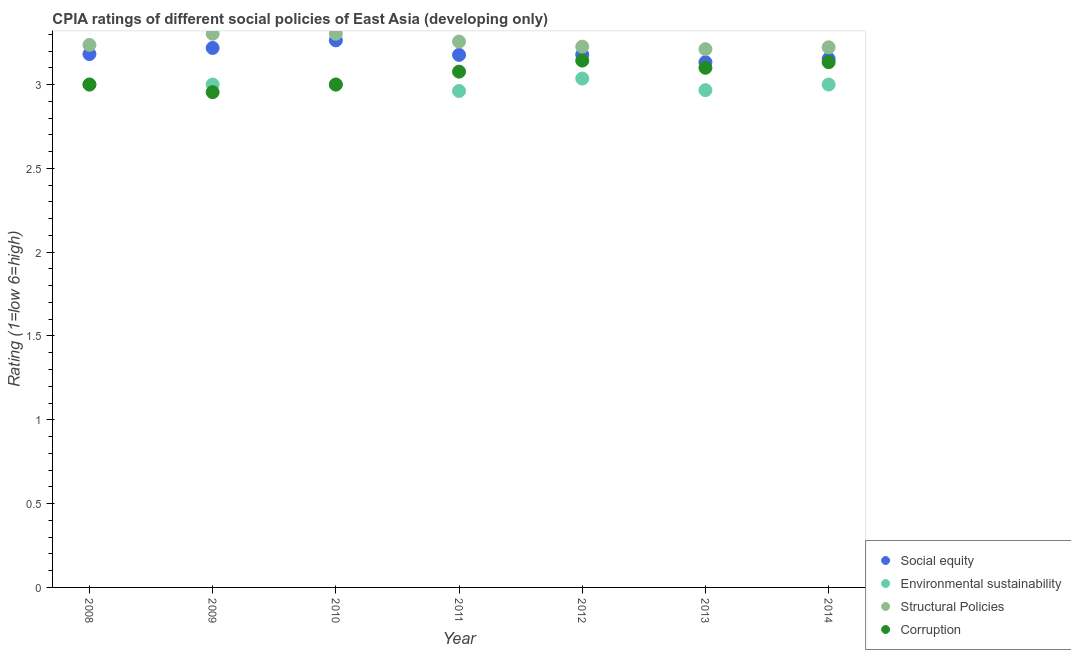How many different coloured dotlines are there?
Your answer should be compact. 4. What is the cpia rating of social equity in 2008?
Ensure brevity in your answer.  3.18. Across all years, what is the maximum cpia rating of social equity?
Offer a very short reply. 3.26. Across all years, what is the minimum cpia rating of social equity?
Make the answer very short. 3.13. In which year was the cpia rating of social equity maximum?
Provide a succinct answer. 2010. What is the total cpia rating of structural policies in the graph?
Give a very brief answer. 22.76. What is the difference between the cpia rating of structural policies in 2008 and that in 2014?
Make the answer very short. 0.01. What is the difference between the cpia rating of corruption in 2012 and the cpia rating of environmental sustainability in 2008?
Provide a short and direct response. 0.14. What is the average cpia rating of structural policies per year?
Keep it short and to the point. 3.25. In the year 2012, what is the difference between the cpia rating of structural policies and cpia rating of environmental sustainability?
Offer a very short reply. 0.19. In how many years, is the cpia rating of corruption greater than 2.7?
Provide a short and direct response. 7. What is the ratio of the cpia rating of structural policies in 2010 to that in 2013?
Your response must be concise. 1.03. Is the cpia rating of environmental sustainability in 2013 less than that in 2014?
Provide a short and direct response. Yes. What is the difference between the highest and the second highest cpia rating of corruption?
Offer a very short reply. 0.01. What is the difference between the highest and the lowest cpia rating of structural policies?
Offer a very short reply. 0.09. In how many years, is the cpia rating of social equity greater than the average cpia rating of social equity taken over all years?
Provide a short and direct response. 2. Is it the case that in every year, the sum of the cpia rating of structural policies and cpia rating of environmental sustainability is greater than the sum of cpia rating of corruption and cpia rating of social equity?
Offer a very short reply. Yes. Does the cpia rating of corruption monotonically increase over the years?
Give a very brief answer. No. How many years are there in the graph?
Give a very brief answer. 7. What is the difference between two consecutive major ticks on the Y-axis?
Keep it short and to the point. 0.5. Does the graph contain any zero values?
Provide a succinct answer. No. How many legend labels are there?
Keep it short and to the point. 4. What is the title of the graph?
Keep it short and to the point. CPIA ratings of different social policies of East Asia (developing only). Does "UNTA" appear as one of the legend labels in the graph?
Provide a short and direct response. No. What is the label or title of the X-axis?
Offer a very short reply. Year. What is the Rating (1=low 6=high) of Social equity in 2008?
Ensure brevity in your answer.  3.18. What is the Rating (1=low 6=high) of Structural Policies in 2008?
Offer a very short reply. 3.24. What is the Rating (1=low 6=high) of Social equity in 2009?
Offer a terse response. 3.22. What is the Rating (1=low 6=high) in Structural Policies in 2009?
Keep it short and to the point. 3.3. What is the Rating (1=low 6=high) of Corruption in 2009?
Keep it short and to the point. 2.95. What is the Rating (1=low 6=high) of Social equity in 2010?
Your answer should be very brief. 3.26. What is the Rating (1=low 6=high) in Structural Policies in 2010?
Provide a succinct answer. 3.3. What is the Rating (1=low 6=high) in Corruption in 2010?
Offer a terse response. 3. What is the Rating (1=low 6=high) in Social equity in 2011?
Ensure brevity in your answer.  3.18. What is the Rating (1=low 6=high) of Environmental sustainability in 2011?
Offer a terse response. 2.96. What is the Rating (1=low 6=high) of Structural Policies in 2011?
Provide a succinct answer. 3.26. What is the Rating (1=low 6=high) of Corruption in 2011?
Make the answer very short. 3.08. What is the Rating (1=low 6=high) of Social equity in 2012?
Your answer should be very brief. 3.18. What is the Rating (1=low 6=high) in Environmental sustainability in 2012?
Your answer should be compact. 3.04. What is the Rating (1=low 6=high) in Structural Policies in 2012?
Offer a terse response. 3.23. What is the Rating (1=low 6=high) in Corruption in 2012?
Offer a very short reply. 3.14. What is the Rating (1=low 6=high) of Social equity in 2013?
Make the answer very short. 3.13. What is the Rating (1=low 6=high) of Environmental sustainability in 2013?
Your response must be concise. 2.97. What is the Rating (1=low 6=high) in Structural Policies in 2013?
Give a very brief answer. 3.21. What is the Rating (1=low 6=high) of Corruption in 2013?
Give a very brief answer. 3.1. What is the Rating (1=low 6=high) of Social equity in 2014?
Offer a very short reply. 3.15. What is the Rating (1=low 6=high) in Environmental sustainability in 2014?
Make the answer very short. 3. What is the Rating (1=low 6=high) of Structural Policies in 2014?
Offer a terse response. 3.22. What is the Rating (1=low 6=high) in Corruption in 2014?
Make the answer very short. 3.13. Across all years, what is the maximum Rating (1=low 6=high) of Social equity?
Offer a very short reply. 3.26. Across all years, what is the maximum Rating (1=low 6=high) in Environmental sustainability?
Keep it short and to the point. 3.04. Across all years, what is the maximum Rating (1=low 6=high) of Structural Policies?
Offer a very short reply. 3.3. Across all years, what is the maximum Rating (1=low 6=high) of Corruption?
Keep it short and to the point. 3.14. Across all years, what is the minimum Rating (1=low 6=high) in Social equity?
Your response must be concise. 3.13. Across all years, what is the minimum Rating (1=low 6=high) in Environmental sustainability?
Give a very brief answer. 2.96. Across all years, what is the minimum Rating (1=low 6=high) in Structural Policies?
Ensure brevity in your answer.  3.21. Across all years, what is the minimum Rating (1=low 6=high) in Corruption?
Offer a terse response. 2.95. What is the total Rating (1=low 6=high) in Social equity in the graph?
Your answer should be compact. 22.31. What is the total Rating (1=low 6=high) in Environmental sustainability in the graph?
Provide a succinct answer. 20.96. What is the total Rating (1=low 6=high) of Structural Policies in the graph?
Make the answer very short. 22.76. What is the total Rating (1=low 6=high) of Corruption in the graph?
Make the answer very short. 21.41. What is the difference between the Rating (1=low 6=high) in Social equity in 2008 and that in 2009?
Provide a succinct answer. -0.04. What is the difference between the Rating (1=low 6=high) of Structural Policies in 2008 and that in 2009?
Keep it short and to the point. -0.07. What is the difference between the Rating (1=low 6=high) of Corruption in 2008 and that in 2009?
Offer a very short reply. 0.05. What is the difference between the Rating (1=low 6=high) in Social equity in 2008 and that in 2010?
Provide a short and direct response. -0.08. What is the difference between the Rating (1=low 6=high) in Structural Policies in 2008 and that in 2010?
Provide a short and direct response. -0.07. What is the difference between the Rating (1=low 6=high) of Corruption in 2008 and that in 2010?
Offer a terse response. 0. What is the difference between the Rating (1=low 6=high) of Social equity in 2008 and that in 2011?
Ensure brevity in your answer.  0. What is the difference between the Rating (1=low 6=high) of Environmental sustainability in 2008 and that in 2011?
Give a very brief answer. 0.04. What is the difference between the Rating (1=low 6=high) of Structural Policies in 2008 and that in 2011?
Your answer should be compact. -0.02. What is the difference between the Rating (1=low 6=high) of Corruption in 2008 and that in 2011?
Provide a short and direct response. -0.08. What is the difference between the Rating (1=low 6=high) of Social equity in 2008 and that in 2012?
Offer a terse response. 0. What is the difference between the Rating (1=low 6=high) in Environmental sustainability in 2008 and that in 2012?
Offer a terse response. -0.04. What is the difference between the Rating (1=low 6=high) in Structural Policies in 2008 and that in 2012?
Offer a terse response. 0.01. What is the difference between the Rating (1=low 6=high) of Corruption in 2008 and that in 2012?
Keep it short and to the point. -0.14. What is the difference between the Rating (1=low 6=high) in Social equity in 2008 and that in 2013?
Ensure brevity in your answer.  0.05. What is the difference between the Rating (1=low 6=high) of Structural Policies in 2008 and that in 2013?
Keep it short and to the point. 0.03. What is the difference between the Rating (1=low 6=high) of Social equity in 2008 and that in 2014?
Give a very brief answer. 0.03. What is the difference between the Rating (1=low 6=high) in Environmental sustainability in 2008 and that in 2014?
Keep it short and to the point. 0. What is the difference between the Rating (1=low 6=high) of Structural Policies in 2008 and that in 2014?
Provide a short and direct response. 0.01. What is the difference between the Rating (1=low 6=high) in Corruption in 2008 and that in 2014?
Your answer should be very brief. -0.13. What is the difference between the Rating (1=low 6=high) of Social equity in 2009 and that in 2010?
Provide a succinct answer. -0.05. What is the difference between the Rating (1=low 6=high) of Structural Policies in 2009 and that in 2010?
Provide a succinct answer. 0. What is the difference between the Rating (1=low 6=high) of Corruption in 2009 and that in 2010?
Offer a very short reply. -0.05. What is the difference between the Rating (1=low 6=high) of Social equity in 2009 and that in 2011?
Make the answer very short. 0.04. What is the difference between the Rating (1=low 6=high) in Environmental sustainability in 2009 and that in 2011?
Make the answer very short. 0.04. What is the difference between the Rating (1=low 6=high) of Structural Policies in 2009 and that in 2011?
Offer a very short reply. 0.05. What is the difference between the Rating (1=low 6=high) in Corruption in 2009 and that in 2011?
Give a very brief answer. -0.12. What is the difference between the Rating (1=low 6=high) of Social equity in 2009 and that in 2012?
Make the answer very short. 0.04. What is the difference between the Rating (1=low 6=high) of Environmental sustainability in 2009 and that in 2012?
Make the answer very short. -0.04. What is the difference between the Rating (1=low 6=high) in Structural Policies in 2009 and that in 2012?
Your response must be concise. 0.08. What is the difference between the Rating (1=low 6=high) in Corruption in 2009 and that in 2012?
Offer a terse response. -0.19. What is the difference between the Rating (1=low 6=high) of Social equity in 2009 and that in 2013?
Provide a short and direct response. 0.08. What is the difference between the Rating (1=low 6=high) in Environmental sustainability in 2009 and that in 2013?
Your answer should be compact. 0.03. What is the difference between the Rating (1=low 6=high) in Structural Policies in 2009 and that in 2013?
Offer a terse response. 0.09. What is the difference between the Rating (1=low 6=high) in Corruption in 2009 and that in 2013?
Provide a succinct answer. -0.15. What is the difference between the Rating (1=low 6=high) of Social equity in 2009 and that in 2014?
Your answer should be very brief. 0.06. What is the difference between the Rating (1=low 6=high) of Environmental sustainability in 2009 and that in 2014?
Ensure brevity in your answer.  0. What is the difference between the Rating (1=low 6=high) in Structural Policies in 2009 and that in 2014?
Your answer should be compact. 0.08. What is the difference between the Rating (1=low 6=high) in Corruption in 2009 and that in 2014?
Keep it short and to the point. -0.18. What is the difference between the Rating (1=low 6=high) of Social equity in 2010 and that in 2011?
Offer a terse response. 0.09. What is the difference between the Rating (1=low 6=high) of Environmental sustainability in 2010 and that in 2011?
Keep it short and to the point. 0.04. What is the difference between the Rating (1=low 6=high) in Structural Policies in 2010 and that in 2011?
Provide a succinct answer. 0.05. What is the difference between the Rating (1=low 6=high) of Corruption in 2010 and that in 2011?
Your answer should be compact. -0.08. What is the difference between the Rating (1=low 6=high) of Social equity in 2010 and that in 2012?
Provide a short and direct response. 0.09. What is the difference between the Rating (1=low 6=high) of Environmental sustainability in 2010 and that in 2012?
Give a very brief answer. -0.04. What is the difference between the Rating (1=low 6=high) of Structural Policies in 2010 and that in 2012?
Give a very brief answer. 0.08. What is the difference between the Rating (1=low 6=high) of Corruption in 2010 and that in 2012?
Provide a succinct answer. -0.14. What is the difference between the Rating (1=low 6=high) of Social equity in 2010 and that in 2013?
Your answer should be very brief. 0.13. What is the difference between the Rating (1=low 6=high) in Structural Policies in 2010 and that in 2013?
Make the answer very short. 0.09. What is the difference between the Rating (1=low 6=high) in Corruption in 2010 and that in 2013?
Keep it short and to the point. -0.1. What is the difference between the Rating (1=low 6=high) in Social equity in 2010 and that in 2014?
Provide a succinct answer. 0.11. What is the difference between the Rating (1=low 6=high) in Environmental sustainability in 2010 and that in 2014?
Provide a short and direct response. 0. What is the difference between the Rating (1=low 6=high) in Structural Policies in 2010 and that in 2014?
Provide a succinct answer. 0.08. What is the difference between the Rating (1=low 6=high) in Corruption in 2010 and that in 2014?
Provide a succinct answer. -0.13. What is the difference between the Rating (1=low 6=high) in Social equity in 2011 and that in 2012?
Make the answer very short. -0. What is the difference between the Rating (1=low 6=high) of Environmental sustainability in 2011 and that in 2012?
Provide a short and direct response. -0.07. What is the difference between the Rating (1=low 6=high) in Structural Policies in 2011 and that in 2012?
Offer a very short reply. 0.03. What is the difference between the Rating (1=low 6=high) in Corruption in 2011 and that in 2012?
Provide a short and direct response. -0.07. What is the difference between the Rating (1=low 6=high) in Social equity in 2011 and that in 2013?
Offer a very short reply. 0.04. What is the difference between the Rating (1=low 6=high) of Environmental sustainability in 2011 and that in 2013?
Ensure brevity in your answer.  -0.01. What is the difference between the Rating (1=low 6=high) of Structural Policies in 2011 and that in 2013?
Ensure brevity in your answer.  0.05. What is the difference between the Rating (1=low 6=high) in Corruption in 2011 and that in 2013?
Give a very brief answer. -0.02. What is the difference between the Rating (1=low 6=high) in Social equity in 2011 and that in 2014?
Your answer should be compact. 0.02. What is the difference between the Rating (1=low 6=high) in Environmental sustainability in 2011 and that in 2014?
Offer a very short reply. -0.04. What is the difference between the Rating (1=low 6=high) in Structural Policies in 2011 and that in 2014?
Give a very brief answer. 0.03. What is the difference between the Rating (1=low 6=high) of Corruption in 2011 and that in 2014?
Provide a succinct answer. -0.06. What is the difference between the Rating (1=low 6=high) in Social equity in 2012 and that in 2013?
Keep it short and to the point. 0.05. What is the difference between the Rating (1=low 6=high) of Environmental sustainability in 2012 and that in 2013?
Your answer should be compact. 0.07. What is the difference between the Rating (1=low 6=high) in Structural Policies in 2012 and that in 2013?
Provide a short and direct response. 0.02. What is the difference between the Rating (1=low 6=high) in Corruption in 2012 and that in 2013?
Give a very brief answer. 0.04. What is the difference between the Rating (1=low 6=high) of Social equity in 2012 and that in 2014?
Offer a terse response. 0.03. What is the difference between the Rating (1=low 6=high) of Environmental sustainability in 2012 and that in 2014?
Your answer should be very brief. 0.04. What is the difference between the Rating (1=low 6=high) in Structural Policies in 2012 and that in 2014?
Offer a very short reply. 0. What is the difference between the Rating (1=low 6=high) of Corruption in 2012 and that in 2014?
Provide a succinct answer. 0.01. What is the difference between the Rating (1=low 6=high) of Social equity in 2013 and that in 2014?
Give a very brief answer. -0.02. What is the difference between the Rating (1=low 6=high) of Environmental sustainability in 2013 and that in 2014?
Your answer should be very brief. -0.03. What is the difference between the Rating (1=low 6=high) in Structural Policies in 2013 and that in 2014?
Give a very brief answer. -0.01. What is the difference between the Rating (1=low 6=high) of Corruption in 2013 and that in 2014?
Your answer should be compact. -0.03. What is the difference between the Rating (1=low 6=high) in Social equity in 2008 and the Rating (1=low 6=high) in Environmental sustainability in 2009?
Your answer should be compact. 0.18. What is the difference between the Rating (1=low 6=high) of Social equity in 2008 and the Rating (1=low 6=high) of Structural Policies in 2009?
Your response must be concise. -0.12. What is the difference between the Rating (1=low 6=high) in Social equity in 2008 and the Rating (1=low 6=high) in Corruption in 2009?
Make the answer very short. 0.23. What is the difference between the Rating (1=low 6=high) of Environmental sustainability in 2008 and the Rating (1=low 6=high) of Structural Policies in 2009?
Provide a short and direct response. -0.3. What is the difference between the Rating (1=low 6=high) of Environmental sustainability in 2008 and the Rating (1=low 6=high) of Corruption in 2009?
Ensure brevity in your answer.  0.05. What is the difference between the Rating (1=low 6=high) of Structural Policies in 2008 and the Rating (1=low 6=high) of Corruption in 2009?
Ensure brevity in your answer.  0.28. What is the difference between the Rating (1=low 6=high) in Social equity in 2008 and the Rating (1=low 6=high) in Environmental sustainability in 2010?
Your answer should be compact. 0.18. What is the difference between the Rating (1=low 6=high) of Social equity in 2008 and the Rating (1=low 6=high) of Structural Policies in 2010?
Your answer should be very brief. -0.12. What is the difference between the Rating (1=low 6=high) of Social equity in 2008 and the Rating (1=low 6=high) of Corruption in 2010?
Offer a terse response. 0.18. What is the difference between the Rating (1=low 6=high) of Environmental sustainability in 2008 and the Rating (1=low 6=high) of Structural Policies in 2010?
Your answer should be compact. -0.3. What is the difference between the Rating (1=low 6=high) in Structural Policies in 2008 and the Rating (1=low 6=high) in Corruption in 2010?
Offer a terse response. 0.24. What is the difference between the Rating (1=low 6=high) of Social equity in 2008 and the Rating (1=low 6=high) of Environmental sustainability in 2011?
Ensure brevity in your answer.  0.22. What is the difference between the Rating (1=low 6=high) of Social equity in 2008 and the Rating (1=low 6=high) of Structural Policies in 2011?
Your answer should be very brief. -0.07. What is the difference between the Rating (1=low 6=high) of Social equity in 2008 and the Rating (1=low 6=high) of Corruption in 2011?
Make the answer very short. 0.1. What is the difference between the Rating (1=low 6=high) of Environmental sustainability in 2008 and the Rating (1=low 6=high) of Structural Policies in 2011?
Your answer should be very brief. -0.26. What is the difference between the Rating (1=low 6=high) in Environmental sustainability in 2008 and the Rating (1=low 6=high) in Corruption in 2011?
Give a very brief answer. -0.08. What is the difference between the Rating (1=low 6=high) in Structural Policies in 2008 and the Rating (1=low 6=high) in Corruption in 2011?
Your response must be concise. 0.16. What is the difference between the Rating (1=low 6=high) in Social equity in 2008 and the Rating (1=low 6=high) in Environmental sustainability in 2012?
Offer a terse response. 0.15. What is the difference between the Rating (1=low 6=high) in Social equity in 2008 and the Rating (1=low 6=high) in Structural Policies in 2012?
Provide a short and direct response. -0.04. What is the difference between the Rating (1=low 6=high) in Social equity in 2008 and the Rating (1=low 6=high) in Corruption in 2012?
Your answer should be compact. 0.04. What is the difference between the Rating (1=low 6=high) in Environmental sustainability in 2008 and the Rating (1=low 6=high) in Structural Policies in 2012?
Keep it short and to the point. -0.23. What is the difference between the Rating (1=low 6=high) of Environmental sustainability in 2008 and the Rating (1=low 6=high) of Corruption in 2012?
Offer a very short reply. -0.14. What is the difference between the Rating (1=low 6=high) in Structural Policies in 2008 and the Rating (1=low 6=high) in Corruption in 2012?
Provide a short and direct response. 0.09. What is the difference between the Rating (1=low 6=high) of Social equity in 2008 and the Rating (1=low 6=high) of Environmental sustainability in 2013?
Offer a very short reply. 0.22. What is the difference between the Rating (1=low 6=high) in Social equity in 2008 and the Rating (1=low 6=high) in Structural Policies in 2013?
Give a very brief answer. -0.03. What is the difference between the Rating (1=low 6=high) of Social equity in 2008 and the Rating (1=low 6=high) of Corruption in 2013?
Keep it short and to the point. 0.08. What is the difference between the Rating (1=low 6=high) in Environmental sustainability in 2008 and the Rating (1=low 6=high) in Structural Policies in 2013?
Offer a very short reply. -0.21. What is the difference between the Rating (1=low 6=high) in Environmental sustainability in 2008 and the Rating (1=low 6=high) in Corruption in 2013?
Your answer should be very brief. -0.1. What is the difference between the Rating (1=low 6=high) in Structural Policies in 2008 and the Rating (1=low 6=high) in Corruption in 2013?
Your answer should be compact. 0.14. What is the difference between the Rating (1=low 6=high) of Social equity in 2008 and the Rating (1=low 6=high) of Environmental sustainability in 2014?
Make the answer very short. 0.18. What is the difference between the Rating (1=low 6=high) of Social equity in 2008 and the Rating (1=low 6=high) of Structural Policies in 2014?
Keep it short and to the point. -0.04. What is the difference between the Rating (1=low 6=high) of Social equity in 2008 and the Rating (1=low 6=high) of Corruption in 2014?
Your answer should be compact. 0.05. What is the difference between the Rating (1=low 6=high) of Environmental sustainability in 2008 and the Rating (1=low 6=high) of Structural Policies in 2014?
Provide a short and direct response. -0.22. What is the difference between the Rating (1=low 6=high) in Environmental sustainability in 2008 and the Rating (1=low 6=high) in Corruption in 2014?
Provide a succinct answer. -0.13. What is the difference between the Rating (1=low 6=high) of Structural Policies in 2008 and the Rating (1=low 6=high) of Corruption in 2014?
Offer a terse response. 0.1. What is the difference between the Rating (1=low 6=high) in Social equity in 2009 and the Rating (1=low 6=high) in Environmental sustainability in 2010?
Provide a succinct answer. 0.22. What is the difference between the Rating (1=low 6=high) in Social equity in 2009 and the Rating (1=low 6=high) in Structural Policies in 2010?
Give a very brief answer. -0.08. What is the difference between the Rating (1=low 6=high) of Social equity in 2009 and the Rating (1=low 6=high) of Corruption in 2010?
Your response must be concise. 0.22. What is the difference between the Rating (1=low 6=high) in Environmental sustainability in 2009 and the Rating (1=low 6=high) in Structural Policies in 2010?
Give a very brief answer. -0.3. What is the difference between the Rating (1=low 6=high) of Environmental sustainability in 2009 and the Rating (1=low 6=high) of Corruption in 2010?
Your response must be concise. 0. What is the difference between the Rating (1=low 6=high) in Structural Policies in 2009 and the Rating (1=low 6=high) in Corruption in 2010?
Provide a short and direct response. 0.3. What is the difference between the Rating (1=low 6=high) in Social equity in 2009 and the Rating (1=low 6=high) in Environmental sustainability in 2011?
Your response must be concise. 0.26. What is the difference between the Rating (1=low 6=high) in Social equity in 2009 and the Rating (1=low 6=high) in Structural Policies in 2011?
Keep it short and to the point. -0.04. What is the difference between the Rating (1=low 6=high) in Social equity in 2009 and the Rating (1=low 6=high) in Corruption in 2011?
Ensure brevity in your answer.  0.14. What is the difference between the Rating (1=low 6=high) of Environmental sustainability in 2009 and the Rating (1=low 6=high) of Structural Policies in 2011?
Make the answer very short. -0.26. What is the difference between the Rating (1=low 6=high) of Environmental sustainability in 2009 and the Rating (1=low 6=high) of Corruption in 2011?
Your response must be concise. -0.08. What is the difference between the Rating (1=low 6=high) of Structural Policies in 2009 and the Rating (1=low 6=high) of Corruption in 2011?
Make the answer very short. 0.23. What is the difference between the Rating (1=low 6=high) of Social equity in 2009 and the Rating (1=low 6=high) of Environmental sustainability in 2012?
Your answer should be very brief. 0.18. What is the difference between the Rating (1=low 6=high) in Social equity in 2009 and the Rating (1=low 6=high) in Structural Policies in 2012?
Provide a short and direct response. -0.01. What is the difference between the Rating (1=low 6=high) of Social equity in 2009 and the Rating (1=low 6=high) of Corruption in 2012?
Ensure brevity in your answer.  0.08. What is the difference between the Rating (1=low 6=high) in Environmental sustainability in 2009 and the Rating (1=low 6=high) in Structural Policies in 2012?
Offer a very short reply. -0.23. What is the difference between the Rating (1=low 6=high) of Environmental sustainability in 2009 and the Rating (1=low 6=high) of Corruption in 2012?
Provide a succinct answer. -0.14. What is the difference between the Rating (1=low 6=high) of Structural Policies in 2009 and the Rating (1=low 6=high) of Corruption in 2012?
Your answer should be compact. 0.16. What is the difference between the Rating (1=low 6=high) in Social equity in 2009 and the Rating (1=low 6=high) in Environmental sustainability in 2013?
Your answer should be very brief. 0.25. What is the difference between the Rating (1=low 6=high) in Social equity in 2009 and the Rating (1=low 6=high) in Structural Policies in 2013?
Make the answer very short. 0.01. What is the difference between the Rating (1=low 6=high) of Social equity in 2009 and the Rating (1=low 6=high) of Corruption in 2013?
Offer a terse response. 0.12. What is the difference between the Rating (1=low 6=high) in Environmental sustainability in 2009 and the Rating (1=low 6=high) in Structural Policies in 2013?
Offer a terse response. -0.21. What is the difference between the Rating (1=low 6=high) in Environmental sustainability in 2009 and the Rating (1=low 6=high) in Corruption in 2013?
Offer a very short reply. -0.1. What is the difference between the Rating (1=low 6=high) of Structural Policies in 2009 and the Rating (1=low 6=high) of Corruption in 2013?
Your response must be concise. 0.2. What is the difference between the Rating (1=low 6=high) of Social equity in 2009 and the Rating (1=low 6=high) of Environmental sustainability in 2014?
Ensure brevity in your answer.  0.22. What is the difference between the Rating (1=low 6=high) in Social equity in 2009 and the Rating (1=low 6=high) in Structural Policies in 2014?
Provide a short and direct response. -0. What is the difference between the Rating (1=low 6=high) in Social equity in 2009 and the Rating (1=low 6=high) in Corruption in 2014?
Provide a short and direct response. 0.08. What is the difference between the Rating (1=low 6=high) in Environmental sustainability in 2009 and the Rating (1=low 6=high) in Structural Policies in 2014?
Offer a very short reply. -0.22. What is the difference between the Rating (1=low 6=high) of Environmental sustainability in 2009 and the Rating (1=low 6=high) of Corruption in 2014?
Ensure brevity in your answer.  -0.13. What is the difference between the Rating (1=low 6=high) of Structural Policies in 2009 and the Rating (1=low 6=high) of Corruption in 2014?
Make the answer very short. 0.17. What is the difference between the Rating (1=low 6=high) of Social equity in 2010 and the Rating (1=low 6=high) of Environmental sustainability in 2011?
Ensure brevity in your answer.  0.3. What is the difference between the Rating (1=low 6=high) in Social equity in 2010 and the Rating (1=low 6=high) in Structural Policies in 2011?
Offer a very short reply. 0.01. What is the difference between the Rating (1=low 6=high) of Social equity in 2010 and the Rating (1=low 6=high) of Corruption in 2011?
Your answer should be compact. 0.19. What is the difference between the Rating (1=low 6=high) in Environmental sustainability in 2010 and the Rating (1=low 6=high) in Structural Policies in 2011?
Ensure brevity in your answer.  -0.26. What is the difference between the Rating (1=low 6=high) in Environmental sustainability in 2010 and the Rating (1=low 6=high) in Corruption in 2011?
Ensure brevity in your answer.  -0.08. What is the difference between the Rating (1=low 6=high) in Structural Policies in 2010 and the Rating (1=low 6=high) in Corruption in 2011?
Keep it short and to the point. 0.23. What is the difference between the Rating (1=low 6=high) in Social equity in 2010 and the Rating (1=low 6=high) in Environmental sustainability in 2012?
Provide a succinct answer. 0.23. What is the difference between the Rating (1=low 6=high) in Social equity in 2010 and the Rating (1=low 6=high) in Structural Policies in 2012?
Offer a terse response. 0.04. What is the difference between the Rating (1=low 6=high) of Social equity in 2010 and the Rating (1=low 6=high) of Corruption in 2012?
Give a very brief answer. 0.12. What is the difference between the Rating (1=low 6=high) in Environmental sustainability in 2010 and the Rating (1=low 6=high) in Structural Policies in 2012?
Ensure brevity in your answer.  -0.23. What is the difference between the Rating (1=low 6=high) of Environmental sustainability in 2010 and the Rating (1=low 6=high) of Corruption in 2012?
Keep it short and to the point. -0.14. What is the difference between the Rating (1=low 6=high) of Structural Policies in 2010 and the Rating (1=low 6=high) of Corruption in 2012?
Your answer should be compact. 0.16. What is the difference between the Rating (1=low 6=high) in Social equity in 2010 and the Rating (1=low 6=high) in Environmental sustainability in 2013?
Offer a very short reply. 0.3. What is the difference between the Rating (1=low 6=high) in Social equity in 2010 and the Rating (1=low 6=high) in Structural Policies in 2013?
Make the answer very short. 0.05. What is the difference between the Rating (1=low 6=high) in Social equity in 2010 and the Rating (1=low 6=high) in Corruption in 2013?
Keep it short and to the point. 0.16. What is the difference between the Rating (1=low 6=high) of Environmental sustainability in 2010 and the Rating (1=low 6=high) of Structural Policies in 2013?
Offer a very short reply. -0.21. What is the difference between the Rating (1=low 6=high) of Structural Policies in 2010 and the Rating (1=low 6=high) of Corruption in 2013?
Make the answer very short. 0.2. What is the difference between the Rating (1=low 6=high) in Social equity in 2010 and the Rating (1=low 6=high) in Environmental sustainability in 2014?
Your answer should be very brief. 0.26. What is the difference between the Rating (1=low 6=high) of Social equity in 2010 and the Rating (1=low 6=high) of Structural Policies in 2014?
Make the answer very short. 0.04. What is the difference between the Rating (1=low 6=high) in Social equity in 2010 and the Rating (1=low 6=high) in Corruption in 2014?
Keep it short and to the point. 0.13. What is the difference between the Rating (1=low 6=high) in Environmental sustainability in 2010 and the Rating (1=low 6=high) in Structural Policies in 2014?
Keep it short and to the point. -0.22. What is the difference between the Rating (1=low 6=high) in Environmental sustainability in 2010 and the Rating (1=low 6=high) in Corruption in 2014?
Keep it short and to the point. -0.13. What is the difference between the Rating (1=low 6=high) in Structural Policies in 2010 and the Rating (1=low 6=high) in Corruption in 2014?
Your response must be concise. 0.17. What is the difference between the Rating (1=low 6=high) in Social equity in 2011 and the Rating (1=low 6=high) in Environmental sustainability in 2012?
Your answer should be compact. 0.14. What is the difference between the Rating (1=low 6=high) of Social equity in 2011 and the Rating (1=low 6=high) of Structural Policies in 2012?
Offer a very short reply. -0.05. What is the difference between the Rating (1=low 6=high) of Social equity in 2011 and the Rating (1=low 6=high) of Corruption in 2012?
Give a very brief answer. 0.03. What is the difference between the Rating (1=low 6=high) in Environmental sustainability in 2011 and the Rating (1=low 6=high) in Structural Policies in 2012?
Offer a very short reply. -0.26. What is the difference between the Rating (1=low 6=high) of Environmental sustainability in 2011 and the Rating (1=low 6=high) of Corruption in 2012?
Provide a succinct answer. -0.18. What is the difference between the Rating (1=low 6=high) of Structural Policies in 2011 and the Rating (1=low 6=high) of Corruption in 2012?
Your answer should be compact. 0.11. What is the difference between the Rating (1=low 6=high) in Social equity in 2011 and the Rating (1=low 6=high) in Environmental sustainability in 2013?
Your answer should be compact. 0.21. What is the difference between the Rating (1=low 6=high) of Social equity in 2011 and the Rating (1=low 6=high) of Structural Policies in 2013?
Make the answer very short. -0.03. What is the difference between the Rating (1=low 6=high) of Social equity in 2011 and the Rating (1=low 6=high) of Corruption in 2013?
Provide a short and direct response. 0.08. What is the difference between the Rating (1=low 6=high) in Environmental sustainability in 2011 and the Rating (1=low 6=high) in Structural Policies in 2013?
Your response must be concise. -0.25. What is the difference between the Rating (1=low 6=high) of Environmental sustainability in 2011 and the Rating (1=low 6=high) of Corruption in 2013?
Offer a very short reply. -0.14. What is the difference between the Rating (1=low 6=high) in Structural Policies in 2011 and the Rating (1=low 6=high) in Corruption in 2013?
Your response must be concise. 0.16. What is the difference between the Rating (1=low 6=high) of Social equity in 2011 and the Rating (1=low 6=high) of Environmental sustainability in 2014?
Your response must be concise. 0.18. What is the difference between the Rating (1=low 6=high) of Social equity in 2011 and the Rating (1=low 6=high) of Structural Policies in 2014?
Make the answer very short. -0.05. What is the difference between the Rating (1=low 6=high) of Social equity in 2011 and the Rating (1=low 6=high) of Corruption in 2014?
Make the answer very short. 0.04. What is the difference between the Rating (1=low 6=high) in Environmental sustainability in 2011 and the Rating (1=low 6=high) in Structural Policies in 2014?
Give a very brief answer. -0.26. What is the difference between the Rating (1=low 6=high) of Environmental sustainability in 2011 and the Rating (1=low 6=high) of Corruption in 2014?
Offer a terse response. -0.17. What is the difference between the Rating (1=low 6=high) of Structural Policies in 2011 and the Rating (1=low 6=high) of Corruption in 2014?
Your answer should be compact. 0.12. What is the difference between the Rating (1=low 6=high) in Social equity in 2012 and the Rating (1=low 6=high) in Environmental sustainability in 2013?
Ensure brevity in your answer.  0.21. What is the difference between the Rating (1=low 6=high) of Social equity in 2012 and the Rating (1=low 6=high) of Structural Policies in 2013?
Offer a terse response. -0.03. What is the difference between the Rating (1=low 6=high) in Social equity in 2012 and the Rating (1=low 6=high) in Corruption in 2013?
Your answer should be compact. 0.08. What is the difference between the Rating (1=low 6=high) in Environmental sustainability in 2012 and the Rating (1=low 6=high) in Structural Policies in 2013?
Your answer should be very brief. -0.18. What is the difference between the Rating (1=low 6=high) in Environmental sustainability in 2012 and the Rating (1=low 6=high) in Corruption in 2013?
Offer a very short reply. -0.06. What is the difference between the Rating (1=low 6=high) of Structural Policies in 2012 and the Rating (1=low 6=high) of Corruption in 2013?
Your answer should be compact. 0.13. What is the difference between the Rating (1=low 6=high) of Social equity in 2012 and the Rating (1=low 6=high) of Environmental sustainability in 2014?
Make the answer very short. 0.18. What is the difference between the Rating (1=low 6=high) in Social equity in 2012 and the Rating (1=low 6=high) in Structural Policies in 2014?
Ensure brevity in your answer.  -0.04. What is the difference between the Rating (1=low 6=high) of Social equity in 2012 and the Rating (1=low 6=high) of Corruption in 2014?
Offer a terse response. 0.05. What is the difference between the Rating (1=low 6=high) in Environmental sustainability in 2012 and the Rating (1=low 6=high) in Structural Policies in 2014?
Keep it short and to the point. -0.19. What is the difference between the Rating (1=low 6=high) of Environmental sustainability in 2012 and the Rating (1=low 6=high) of Corruption in 2014?
Keep it short and to the point. -0.1. What is the difference between the Rating (1=low 6=high) in Structural Policies in 2012 and the Rating (1=low 6=high) in Corruption in 2014?
Your answer should be very brief. 0.09. What is the difference between the Rating (1=low 6=high) of Social equity in 2013 and the Rating (1=low 6=high) of Environmental sustainability in 2014?
Offer a terse response. 0.13. What is the difference between the Rating (1=low 6=high) in Social equity in 2013 and the Rating (1=low 6=high) in Structural Policies in 2014?
Make the answer very short. -0.09. What is the difference between the Rating (1=low 6=high) of Environmental sustainability in 2013 and the Rating (1=low 6=high) of Structural Policies in 2014?
Provide a short and direct response. -0.26. What is the difference between the Rating (1=low 6=high) of Environmental sustainability in 2013 and the Rating (1=low 6=high) of Corruption in 2014?
Offer a terse response. -0.17. What is the difference between the Rating (1=low 6=high) in Structural Policies in 2013 and the Rating (1=low 6=high) in Corruption in 2014?
Provide a succinct answer. 0.08. What is the average Rating (1=low 6=high) in Social equity per year?
Your answer should be compact. 3.19. What is the average Rating (1=low 6=high) in Environmental sustainability per year?
Your answer should be very brief. 2.99. What is the average Rating (1=low 6=high) in Structural Policies per year?
Ensure brevity in your answer.  3.25. What is the average Rating (1=low 6=high) in Corruption per year?
Keep it short and to the point. 3.06. In the year 2008, what is the difference between the Rating (1=low 6=high) in Social equity and Rating (1=low 6=high) in Environmental sustainability?
Keep it short and to the point. 0.18. In the year 2008, what is the difference between the Rating (1=low 6=high) of Social equity and Rating (1=low 6=high) of Structural Policies?
Your answer should be compact. -0.05. In the year 2008, what is the difference between the Rating (1=low 6=high) in Social equity and Rating (1=low 6=high) in Corruption?
Make the answer very short. 0.18. In the year 2008, what is the difference between the Rating (1=low 6=high) in Environmental sustainability and Rating (1=low 6=high) in Structural Policies?
Ensure brevity in your answer.  -0.24. In the year 2008, what is the difference between the Rating (1=low 6=high) of Structural Policies and Rating (1=low 6=high) of Corruption?
Make the answer very short. 0.24. In the year 2009, what is the difference between the Rating (1=low 6=high) of Social equity and Rating (1=low 6=high) of Environmental sustainability?
Make the answer very short. 0.22. In the year 2009, what is the difference between the Rating (1=low 6=high) of Social equity and Rating (1=low 6=high) of Structural Policies?
Make the answer very short. -0.08. In the year 2009, what is the difference between the Rating (1=low 6=high) of Social equity and Rating (1=low 6=high) of Corruption?
Make the answer very short. 0.26. In the year 2009, what is the difference between the Rating (1=low 6=high) of Environmental sustainability and Rating (1=low 6=high) of Structural Policies?
Your answer should be very brief. -0.3. In the year 2009, what is the difference between the Rating (1=low 6=high) of Environmental sustainability and Rating (1=low 6=high) of Corruption?
Ensure brevity in your answer.  0.05. In the year 2009, what is the difference between the Rating (1=low 6=high) in Structural Policies and Rating (1=low 6=high) in Corruption?
Provide a short and direct response. 0.35. In the year 2010, what is the difference between the Rating (1=low 6=high) of Social equity and Rating (1=low 6=high) of Environmental sustainability?
Your answer should be compact. 0.26. In the year 2010, what is the difference between the Rating (1=low 6=high) in Social equity and Rating (1=low 6=high) in Structural Policies?
Provide a succinct answer. -0.04. In the year 2010, what is the difference between the Rating (1=low 6=high) of Social equity and Rating (1=low 6=high) of Corruption?
Offer a terse response. 0.26. In the year 2010, what is the difference between the Rating (1=low 6=high) of Environmental sustainability and Rating (1=low 6=high) of Structural Policies?
Make the answer very short. -0.3. In the year 2010, what is the difference between the Rating (1=low 6=high) in Structural Policies and Rating (1=low 6=high) in Corruption?
Provide a short and direct response. 0.3. In the year 2011, what is the difference between the Rating (1=low 6=high) of Social equity and Rating (1=low 6=high) of Environmental sustainability?
Give a very brief answer. 0.22. In the year 2011, what is the difference between the Rating (1=low 6=high) in Social equity and Rating (1=low 6=high) in Structural Policies?
Your response must be concise. -0.08. In the year 2011, what is the difference between the Rating (1=low 6=high) of Environmental sustainability and Rating (1=low 6=high) of Structural Policies?
Your response must be concise. -0.29. In the year 2011, what is the difference between the Rating (1=low 6=high) in Environmental sustainability and Rating (1=low 6=high) in Corruption?
Give a very brief answer. -0.12. In the year 2011, what is the difference between the Rating (1=low 6=high) of Structural Policies and Rating (1=low 6=high) of Corruption?
Provide a succinct answer. 0.18. In the year 2012, what is the difference between the Rating (1=low 6=high) of Social equity and Rating (1=low 6=high) of Environmental sustainability?
Offer a very short reply. 0.14. In the year 2012, what is the difference between the Rating (1=low 6=high) of Social equity and Rating (1=low 6=high) of Structural Policies?
Ensure brevity in your answer.  -0.05. In the year 2012, what is the difference between the Rating (1=low 6=high) of Social equity and Rating (1=low 6=high) of Corruption?
Offer a terse response. 0.04. In the year 2012, what is the difference between the Rating (1=low 6=high) in Environmental sustainability and Rating (1=low 6=high) in Structural Policies?
Give a very brief answer. -0.19. In the year 2012, what is the difference between the Rating (1=low 6=high) of Environmental sustainability and Rating (1=low 6=high) of Corruption?
Provide a succinct answer. -0.11. In the year 2012, what is the difference between the Rating (1=low 6=high) in Structural Policies and Rating (1=low 6=high) in Corruption?
Your answer should be very brief. 0.08. In the year 2013, what is the difference between the Rating (1=low 6=high) in Social equity and Rating (1=low 6=high) in Structural Policies?
Your answer should be compact. -0.08. In the year 2013, what is the difference between the Rating (1=low 6=high) in Social equity and Rating (1=low 6=high) in Corruption?
Your answer should be compact. 0.03. In the year 2013, what is the difference between the Rating (1=low 6=high) of Environmental sustainability and Rating (1=low 6=high) of Structural Policies?
Your answer should be very brief. -0.24. In the year 2013, what is the difference between the Rating (1=low 6=high) of Environmental sustainability and Rating (1=low 6=high) of Corruption?
Give a very brief answer. -0.13. In the year 2014, what is the difference between the Rating (1=low 6=high) of Social equity and Rating (1=low 6=high) of Environmental sustainability?
Ensure brevity in your answer.  0.15. In the year 2014, what is the difference between the Rating (1=low 6=high) in Social equity and Rating (1=low 6=high) in Structural Policies?
Provide a succinct answer. -0.07. In the year 2014, what is the difference between the Rating (1=low 6=high) of Environmental sustainability and Rating (1=low 6=high) of Structural Policies?
Keep it short and to the point. -0.22. In the year 2014, what is the difference between the Rating (1=low 6=high) of Environmental sustainability and Rating (1=low 6=high) of Corruption?
Give a very brief answer. -0.13. In the year 2014, what is the difference between the Rating (1=low 6=high) of Structural Policies and Rating (1=low 6=high) of Corruption?
Offer a very short reply. 0.09. What is the ratio of the Rating (1=low 6=high) in Social equity in 2008 to that in 2009?
Offer a very short reply. 0.99. What is the ratio of the Rating (1=low 6=high) in Environmental sustainability in 2008 to that in 2009?
Your answer should be very brief. 1. What is the ratio of the Rating (1=low 6=high) in Structural Policies in 2008 to that in 2009?
Provide a succinct answer. 0.98. What is the ratio of the Rating (1=low 6=high) of Corruption in 2008 to that in 2009?
Make the answer very short. 1.02. What is the ratio of the Rating (1=low 6=high) of Social equity in 2008 to that in 2010?
Make the answer very short. 0.97. What is the ratio of the Rating (1=low 6=high) of Environmental sustainability in 2008 to that in 2010?
Provide a short and direct response. 1. What is the ratio of the Rating (1=low 6=high) in Structural Policies in 2008 to that in 2010?
Offer a terse response. 0.98. What is the ratio of the Rating (1=low 6=high) in Environmental sustainability in 2008 to that in 2011?
Provide a short and direct response. 1.01. What is the ratio of the Rating (1=low 6=high) in Social equity in 2008 to that in 2012?
Make the answer very short. 1. What is the ratio of the Rating (1=low 6=high) in Corruption in 2008 to that in 2012?
Provide a succinct answer. 0.95. What is the ratio of the Rating (1=low 6=high) in Social equity in 2008 to that in 2013?
Make the answer very short. 1.02. What is the ratio of the Rating (1=low 6=high) in Environmental sustainability in 2008 to that in 2013?
Provide a succinct answer. 1.01. What is the ratio of the Rating (1=low 6=high) of Structural Policies in 2008 to that in 2013?
Your answer should be compact. 1.01. What is the ratio of the Rating (1=low 6=high) in Corruption in 2008 to that in 2013?
Give a very brief answer. 0.97. What is the ratio of the Rating (1=low 6=high) of Structural Policies in 2008 to that in 2014?
Offer a very short reply. 1. What is the ratio of the Rating (1=low 6=high) of Corruption in 2008 to that in 2014?
Your answer should be very brief. 0.96. What is the ratio of the Rating (1=low 6=high) in Social equity in 2009 to that in 2010?
Offer a terse response. 0.99. What is the ratio of the Rating (1=low 6=high) in Structural Policies in 2009 to that in 2010?
Ensure brevity in your answer.  1. What is the ratio of the Rating (1=low 6=high) in Social equity in 2009 to that in 2011?
Your response must be concise. 1.01. What is the ratio of the Rating (1=low 6=high) of Structural Policies in 2009 to that in 2011?
Give a very brief answer. 1.01. What is the ratio of the Rating (1=low 6=high) in Corruption in 2009 to that in 2011?
Your response must be concise. 0.96. What is the ratio of the Rating (1=low 6=high) in Social equity in 2009 to that in 2012?
Your response must be concise. 1.01. What is the ratio of the Rating (1=low 6=high) in Structural Policies in 2009 to that in 2012?
Your answer should be compact. 1.02. What is the ratio of the Rating (1=low 6=high) in Corruption in 2009 to that in 2012?
Your answer should be compact. 0.94. What is the ratio of the Rating (1=low 6=high) in Social equity in 2009 to that in 2013?
Your answer should be very brief. 1.03. What is the ratio of the Rating (1=low 6=high) of Environmental sustainability in 2009 to that in 2013?
Your answer should be compact. 1.01. What is the ratio of the Rating (1=low 6=high) of Structural Policies in 2009 to that in 2013?
Your answer should be compact. 1.03. What is the ratio of the Rating (1=low 6=high) in Corruption in 2009 to that in 2013?
Offer a very short reply. 0.95. What is the ratio of the Rating (1=low 6=high) of Social equity in 2009 to that in 2014?
Give a very brief answer. 1.02. What is the ratio of the Rating (1=low 6=high) of Structural Policies in 2009 to that in 2014?
Your answer should be compact. 1.03. What is the ratio of the Rating (1=low 6=high) in Corruption in 2009 to that in 2014?
Your answer should be very brief. 0.94. What is the ratio of the Rating (1=low 6=high) of Social equity in 2010 to that in 2011?
Your answer should be compact. 1.03. What is the ratio of the Rating (1=low 6=high) in Environmental sustainability in 2010 to that in 2011?
Make the answer very short. 1.01. What is the ratio of the Rating (1=low 6=high) in Structural Policies in 2010 to that in 2011?
Provide a succinct answer. 1.01. What is the ratio of the Rating (1=low 6=high) in Corruption in 2010 to that in 2011?
Your response must be concise. 0.97. What is the ratio of the Rating (1=low 6=high) in Social equity in 2010 to that in 2012?
Provide a short and direct response. 1.03. What is the ratio of the Rating (1=low 6=high) of Structural Policies in 2010 to that in 2012?
Provide a short and direct response. 1.02. What is the ratio of the Rating (1=low 6=high) in Corruption in 2010 to that in 2012?
Give a very brief answer. 0.95. What is the ratio of the Rating (1=low 6=high) in Social equity in 2010 to that in 2013?
Your response must be concise. 1.04. What is the ratio of the Rating (1=low 6=high) in Environmental sustainability in 2010 to that in 2013?
Your answer should be compact. 1.01. What is the ratio of the Rating (1=low 6=high) of Structural Policies in 2010 to that in 2013?
Provide a succinct answer. 1.03. What is the ratio of the Rating (1=low 6=high) of Social equity in 2010 to that in 2014?
Offer a terse response. 1.03. What is the ratio of the Rating (1=low 6=high) of Structural Policies in 2010 to that in 2014?
Provide a succinct answer. 1.03. What is the ratio of the Rating (1=low 6=high) in Corruption in 2010 to that in 2014?
Provide a short and direct response. 0.96. What is the ratio of the Rating (1=low 6=high) in Environmental sustainability in 2011 to that in 2012?
Your answer should be compact. 0.98. What is the ratio of the Rating (1=low 6=high) of Structural Policies in 2011 to that in 2012?
Your answer should be very brief. 1.01. What is the ratio of the Rating (1=low 6=high) of Corruption in 2011 to that in 2012?
Provide a succinct answer. 0.98. What is the ratio of the Rating (1=low 6=high) of Social equity in 2011 to that in 2013?
Make the answer very short. 1.01. What is the ratio of the Rating (1=low 6=high) of Structural Policies in 2011 to that in 2013?
Your answer should be very brief. 1.01. What is the ratio of the Rating (1=low 6=high) of Social equity in 2011 to that in 2014?
Provide a succinct answer. 1.01. What is the ratio of the Rating (1=low 6=high) of Environmental sustainability in 2011 to that in 2014?
Keep it short and to the point. 0.99. What is the ratio of the Rating (1=low 6=high) of Structural Policies in 2011 to that in 2014?
Keep it short and to the point. 1.01. What is the ratio of the Rating (1=low 6=high) of Social equity in 2012 to that in 2013?
Your answer should be compact. 1.01. What is the ratio of the Rating (1=low 6=high) in Environmental sustainability in 2012 to that in 2013?
Keep it short and to the point. 1.02. What is the ratio of the Rating (1=low 6=high) of Structural Policies in 2012 to that in 2013?
Your answer should be very brief. 1. What is the ratio of the Rating (1=low 6=high) in Corruption in 2012 to that in 2013?
Your response must be concise. 1.01. What is the ratio of the Rating (1=low 6=high) in Environmental sustainability in 2012 to that in 2014?
Your answer should be compact. 1.01. What is the ratio of the Rating (1=low 6=high) in Social equity in 2013 to that in 2014?
Offer a very short reply. 0.99. What is the ratio of the Rating (1=low 6=high) in Environmental sustainability in 2013 to that in 2014?
Your answer should be compact. 0.99. What is the ratio of the Rating (1=low 6=high) in Structural Policies in 2013 to that in 2014?
Give a very brief answer. 1. What is the ratio of the Rating (1=low 6=high) in Corruption in 2013 to that in 2014?
Give a very brief answer. 0.99. What is the difference between the highest and the second highest Rating (1=low 6=high) in Social equity?
Make the answer very short. 0.05. What is the difference between the highest and the second highest Rating (1=low 6=high) of Environmental sustainability?
Give a very brief answer. 0.04. What is the difference between the highest and the second highest Rating (1=low 6=high) of Corruption?
Your response must be concise. 0.01. What is the difference between the highest and the lowest Rating (1=low 6=high) of Social equity?
Offer a terse response. 0.13. What is the difference between the highest and the lowest Rating (1=low 6=high) of Environmental sustainability?
Offer a very short reply. 0.07. What is the difference between the highest and the lowest Rating (1=low 6=high) in Structural Policies?
Your answer should be very brief. 0.09. What is the difference between the highest and the lowest Rating (1=low 6=high) in Corruption?
Give a very brief answer. 0.19. 